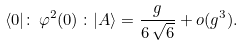<formula> <loc_0><loc_0><loc_500><loc_500>\langle 0 | \colon \, \varphi ^ { 2 } ( 0 ) \, \colon | A \rangle = \frac { g } { 6 \, \sqrt { 6 } } + o ( g ^ { 3 } ) .</formula> 